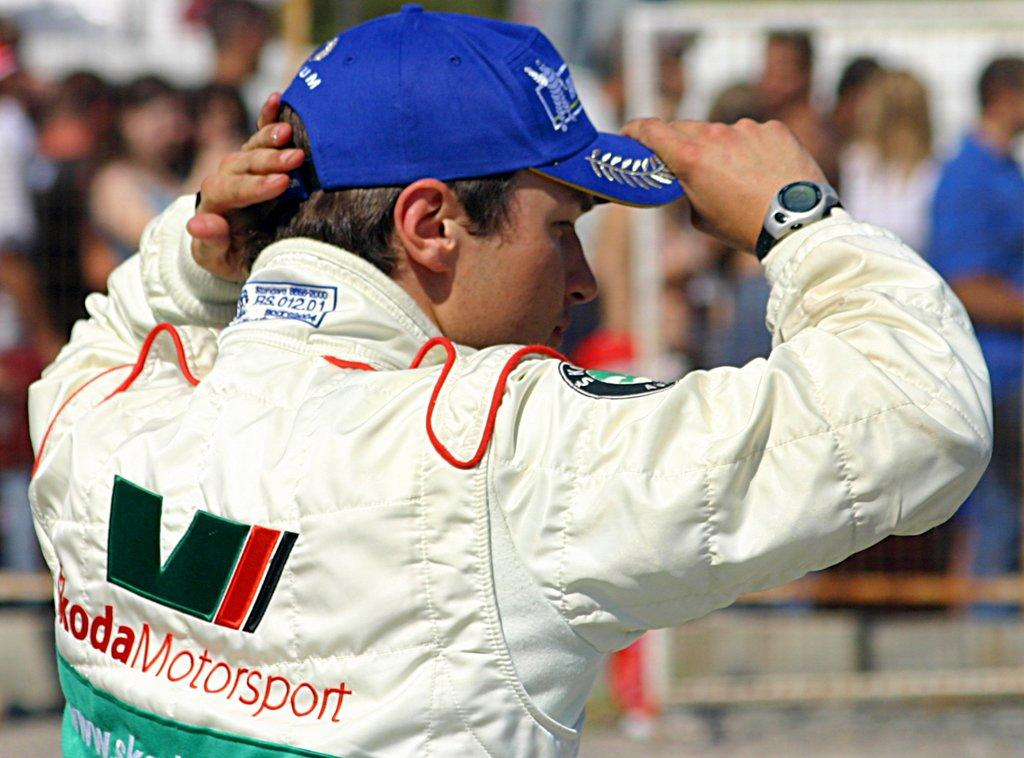<image>
Create a compact narrative representing the image presented. A kodaMotors logo is on the back of a man's jacket. 